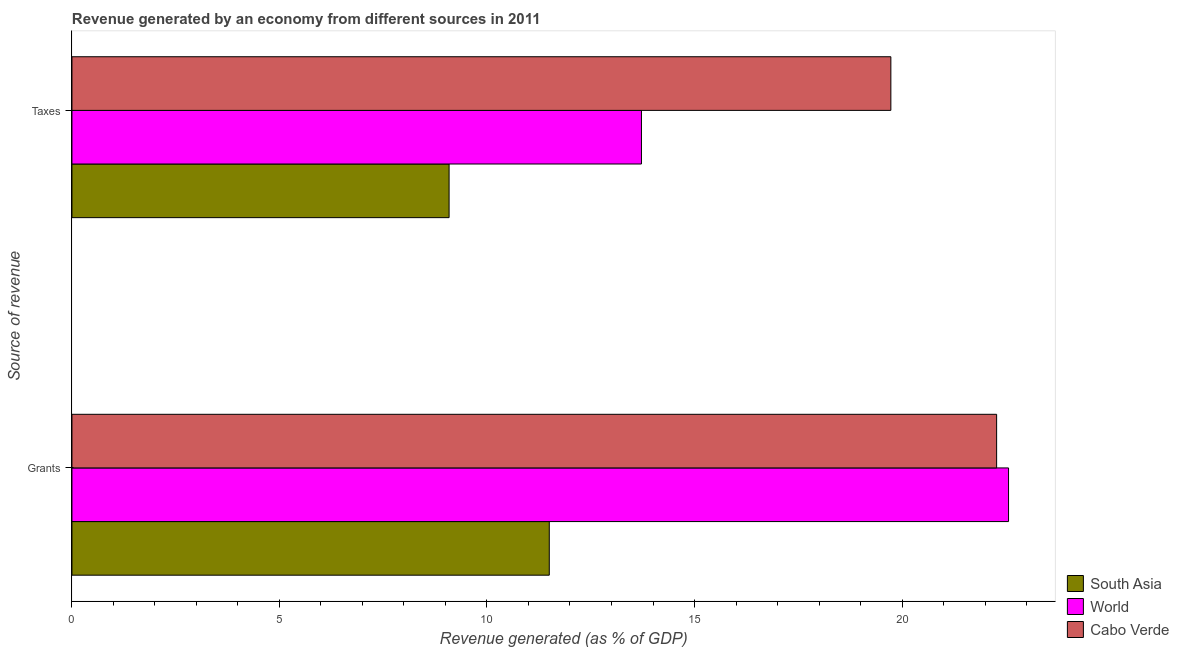What is the label of the 2nd group of bars from the top?
Your answer should be compact. Grants. What is the revenue generated by grants in World?
Make the answer very short. 22.57. Across all countries, what is the maximum revenue generated by taxes?
Offer a very short reply. 19.73. Across all countries, what is the minimum revenue generated by taxes?
Your answer should be very brief. 9.09. What is the total revenue generated by grants in the graph?
Ensure brevity in your answer.  56.35. What is the difference between the revenue generated by grants in South Asia and that in Cabo Verde?
Your answer should be compact. -10.78. What is the difference between the revenue generated by grants in Cabo Verde and the revenue generated by taxes in South Asia?
Offer a terse response. 13.19. What is the average revenue generated by taxes per country?
Keep it short and to the point. 14.18. What is the difference between the revenue generated by grants and revenue generated by taxes in World?
Your response must be concise. 8.84. In how many countries, is the revenue generated by grants greater than 9 %?
Provide a short and direct response. 3. What is the ratio of the revenue generated by taxes in South Asia to that in World?
Give a very brief answer. 0.66. Is the revenue generated by grants in South Asia less than that in Cabo Verde?
Make the answer very short. Yes. What does the 2nd bar from the top in Taxes represents?
Provide a succinct answer. World. What does the 3rd bar from the bottom in Taxes represents?
Keep it short and to the point. Cabo Verde. How many bars are there?
Keep it short and to the point. 6. What is the title of the graph?
Your response must be concise. Revenue generated by an economy from different sources in 2011. What is the label or title of the X-axis?
Provide a succinct answer. Revenue generated (as % of GDP). What is the label or title of the Y-axis?
Your response must be concise. Source of revenue. What is the Revenue generated (as % of GDP) in South Asia in Grants?
Your response must be concise. 11.5. What is the Revenue generated (as % of GDP) in World in Grants?
Provide a short and direct response. 22.57. What is the Revenue generated (as % of GDP) of Cabo Verde in Grants?
Your response must be concise. 22.28. What is the Revenue generated (as % of GDP) of South Asia in Taxes?
Provide a short and direct response. 9.09. What is the Revenue generated (as % of GDP) of World in Taxes?
Make the answer very short. 13.72. What is the Revenue generated (as % of GDP) of Cabo Verde in Taxes?
Give a very brief answer. 19.73. Across all Source of revenue, what is the maximum Revenue generated (as % of GDP) in South Asia?
Your answer should be very brief. 11.5. Across all Source of revenue, what is the maximum Revenue generated (as % of GDP) in World?
Offer a very short reply. 22.57. Across all Source of revenue, what is the maximum Revenue generated (as % of GDP) in Cabo Verde?
Offer a very short reply. 22.28. Across all Source of revenue, what is the minimum Revenue generated (as % of GDP) in South Asia?
Your answer should be very brief. 9.09. Across all Source of revenue, what is the minimum Revenue generated (as % of GDP) in World?
Your response must be concise. 13.72. Across all Source of revenue, what is the minimum Revenue generated (as % of GDP) in Cabo Verde?
Offer a terse response. 19.73. What is the total Revenue generated (as % of GDP) of South Asia in the graph?
Offer a very short reply. 20.59. What is the total Revenue generated (as % of GDP) in World in the graph?
Give a very brief answer. 36.29. What is the total Revenue generated (as % of GDP) in Cabo Verde in the graph?
Your answer should be compact. 42.01. What is the difference between the Revenue generated (as % of GDP) in South Asia in Grants and that in Taxes?
Offer a terse response. 2.41. What is the difference between the Revenue generated (as % of GDP) of World in Grants and that in Taxes?
Provide a short and direct response. 8.84. What is the difference between the Revenue generated (as % of GDP) of Cabo Verde in Grants and that in Taxes?
Your response must be concise. 2.55. What is the difference between the Revenue generated (as % of GDP) of South Asia in Grants and the Revenue generated (as % of GDP) of World in Taxes?
Provide a short and direct response. -2.22. What is the difference between the Revenue generated (as % of GDP) in South Asia in Grants and the Revenue generated (as % of GDP) in Cabo Verde in Taxes?
Your answer should be compact. -8.23. What is the difference between the Revenue generated (as % of GDP) of World in Grants and the Revenue generated (as % of GDP) of Cabo Verde in Taxes?
Your answer should be compact. 2.84. What is the average Revenue generated (as % of GDP) of South Asia per Source of revenue?
Your answer should be compact. 10.29. What is the average Revenue generated (as % of GDP) in World per Source of revenue?
Offer a very short reply. 18.14. What is the average Revenue generated (as % of GDP) of Cabo Verde per Source of revenue?
Give a very brief answer. 21.01. What is the difference between the Revenue generated (as % of GDP) in South Asia and Revenue generated (as % of GDP) in World in Grants?
Make the answer very short. -11.07. What is the difference between the Revenue generated (as % of GDP) in South Asia and Revenue generated (as % of GDP) in Cabo Verde in Grants?
Make the answer very short. -10.78. What is the difference between the Revenue generated (as % of GDP) in World and Revenue generated (as % of GDP) in Cabo Verde in Grants?
Make the answer very short. 0.29. What is the difference between the Revenue generated (as % of GDP) of South Asia and Revenue generated (as % of GDP) of World in Taxes?
Keep it short and to the point. -4.63. What is the difference between the Revenue generated (as % of GDP) of South Asia and Revenue generated (as % of GDP) of Cabo Verde in Taxes?
Make the answer very short. -10.64. What is the difference between the Revenue generated (as % of GDP) in World and Revenue generated (as % of GDP) in Cabo Verde in Taxes?
Give a very brief answer. -6.01. What is the ratio of the Revenue generated (as % of GDP) of South Asia in Grants to that in Taxes?
Your answer should be very brief. 1.27. What is the ratio of the Revenue generated (as % of GDP) in World in Grants to that in Taxes?
Your answer should be compact. 1.64. What is the ratio of the Revenue generated (as % of GDP) in Cabo Verde in Grants to that in Taxes?
Your answer should be very brief. 1.13. What is the difference between the highest and the second highest Revenue generated (as % of GDP) in South Asia?
Your response must be concise. 2.41. What is the difference between the highest and the second highest Revenue generated (as % of GDP) in World?
Provide a short and direct response. 8.84. What is the difference between the highest and the second highest Revenue generated (as % of GDP) of Cabo Verde?
Your response must be concise. 2.55. What is the difference between the highest and the lowest Revenue generated (as % of GDP) in South Asia?
Your response must be concise. 2.41. What is the difference between the highest and the lowest Revenue generated (as % of GDP) in World?
Give a very brief answer. 8.84. What is the difference between the highest and the lowest Revenue generated (as % of GDP) of Cabo Verde?
Your answer should be compact. 2.55. 